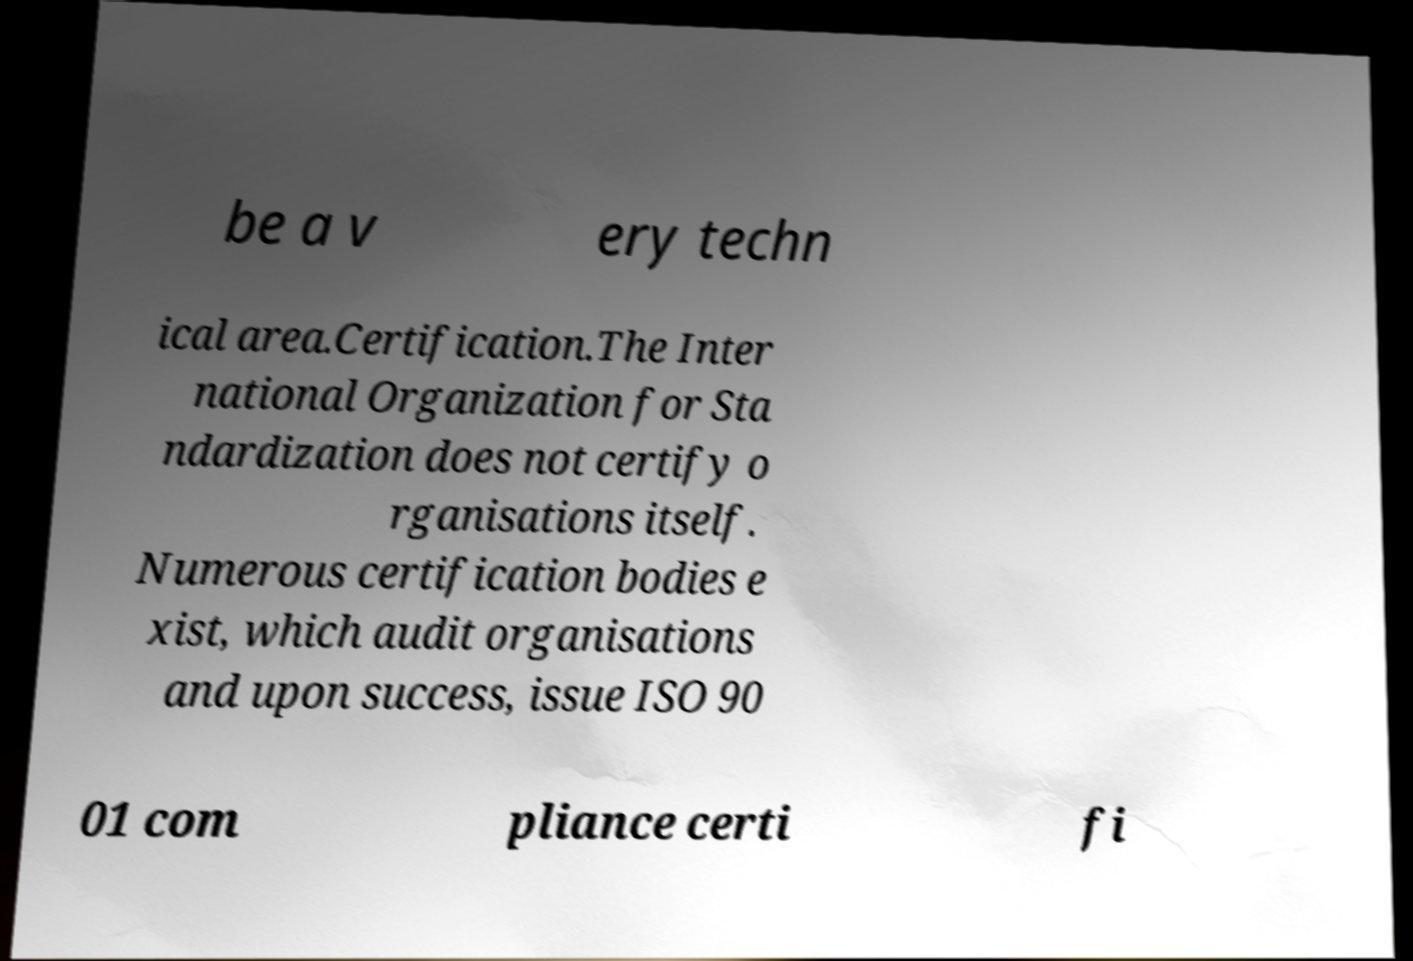I need the written content from this picture converted into text. Can you do that? be a v ery techn ical area.Certification.The Inter national Organization for Sta ndardization does not certify o rganisations itself. Numerous certification bodies e xist, which audit organisations and upon success, issue ISO 90 01 com pliance certi fi 